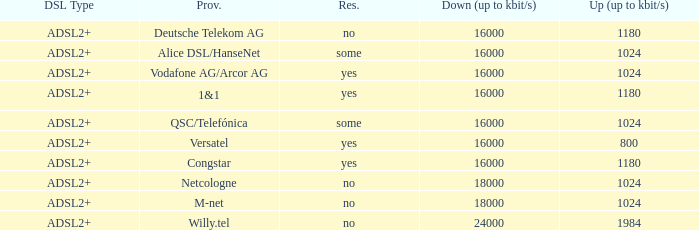Would you be able to parse every entry in this table? {'header': ['DSL Type', 'Prov.', 'Res.', 'Down (up to kbit/s)', 'Up (up to kbit/s)'], 'rows': [['ADSL2+', 'Deutsche Telekom AG', 'no', '16000', '1180'], ['ADSL2+', 'Alice DSL/HanseNet', 'some', '16000', '1024'], ['ADSL2+', 'Vodafone AG/Arcor AG', 'yes', '16000', '1024'], ['ADSL2+', '1&1', 'yes', '16000', '1180'], ['ADSL2+', 'QSC/Telefónica', 'some', '16000', '1024'], ['ADSL2+', 'Versatel', 'yes', '16000', '800'], ['ADSL2+', 'Congstar', 'yes', '16000', '1180'], ['ADSL2+', 'Netcologne', 'no', '18000', '1024'], ['ADSL2+', 'M-net', 'no', '18000', '1024'], ['ADSL2+', 'Willy.tel', 'no', '24000', '1984']]} What is the resale category for the provider NetCologne? No. 